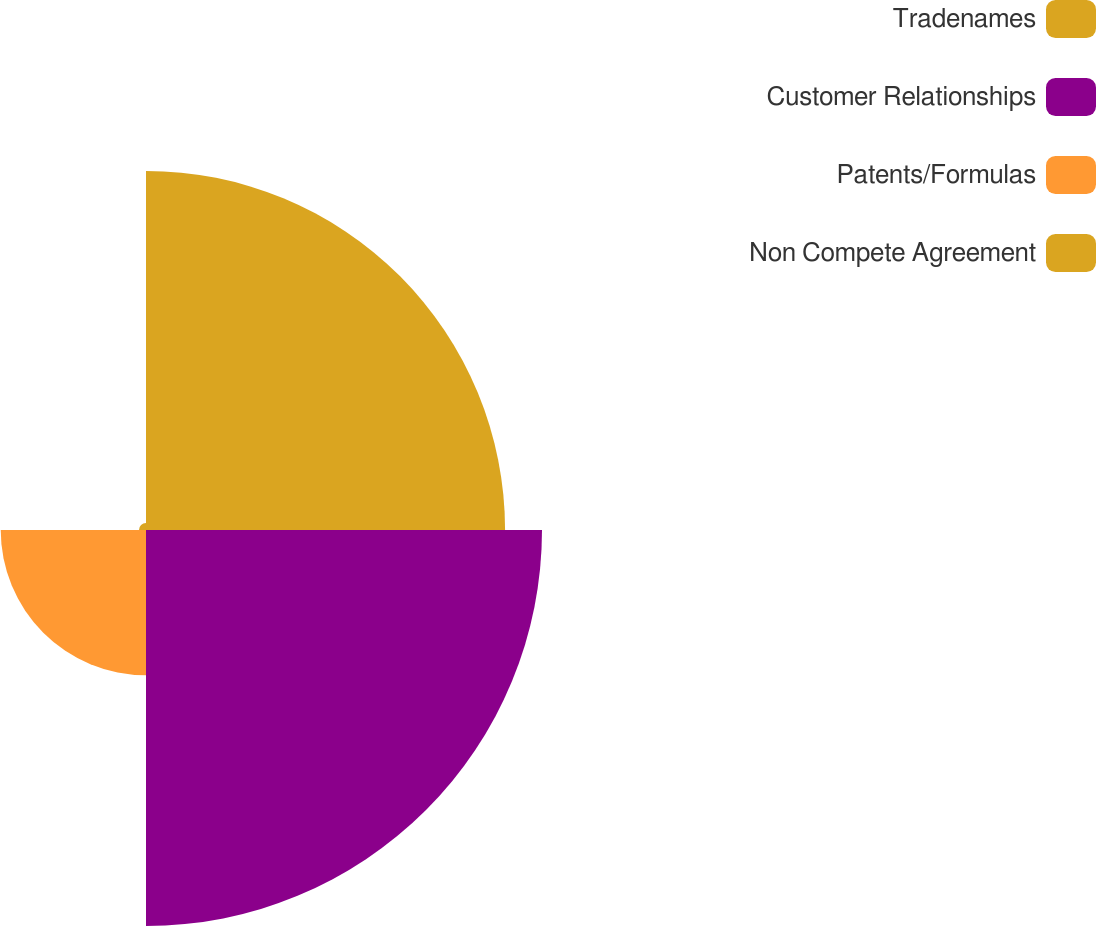Convert chart. <chart><loc_0><loc_0><loc_500><loc_500><pie_chart><fcel>Tradenames<fcel>Customer Relationships<fcel>Patents/Formulas<fcel>Non Compete Agreement<nl><fcel>39.57%<fcel>43.64%<fcel>16.01%<fcel>0.77%<nl></chart> 